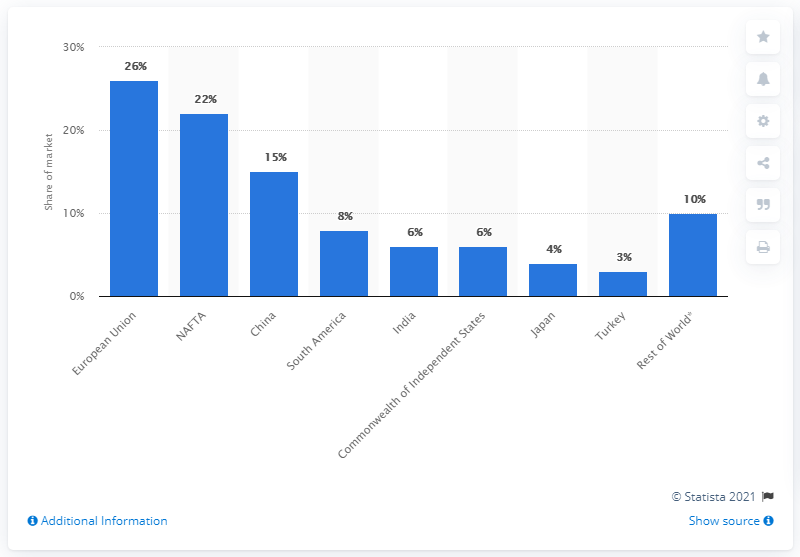Mention a couple of crucial points in this snapshot. The country of China is considered to be one of the fastest growing markets, renowned for its impressive economic development and thriving business environment. 